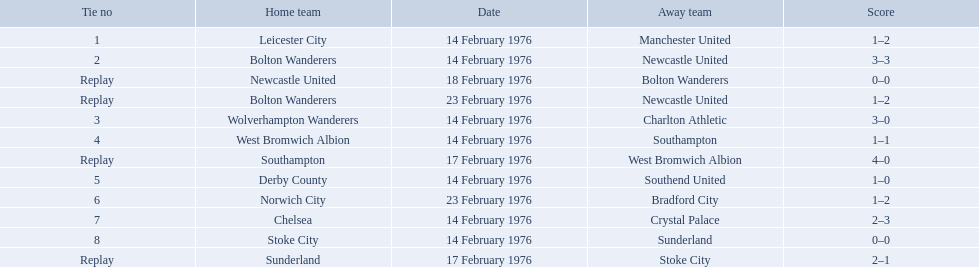What is the game at the top of the table? 1. Who is the home team for this game? Leicester City. 